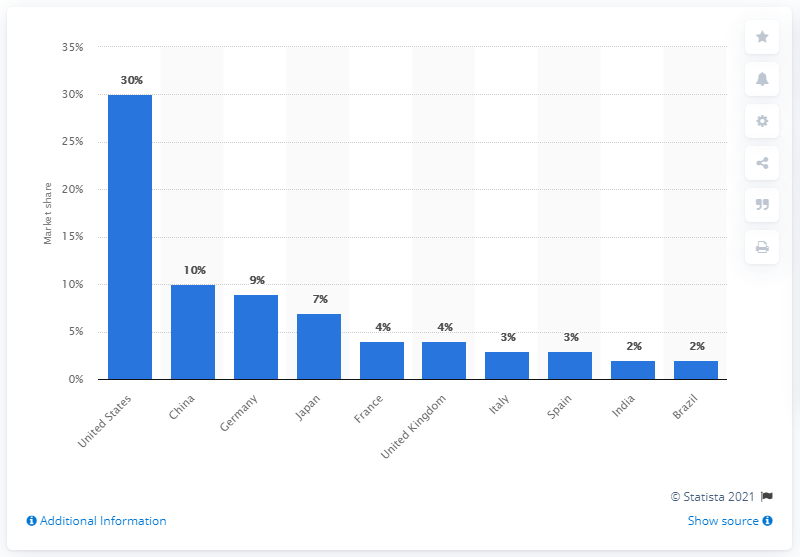Outline some significant characteristics in this image. The United States accounted for approximately 30% of the global book publishing market in terms of total sales as of 2017. 